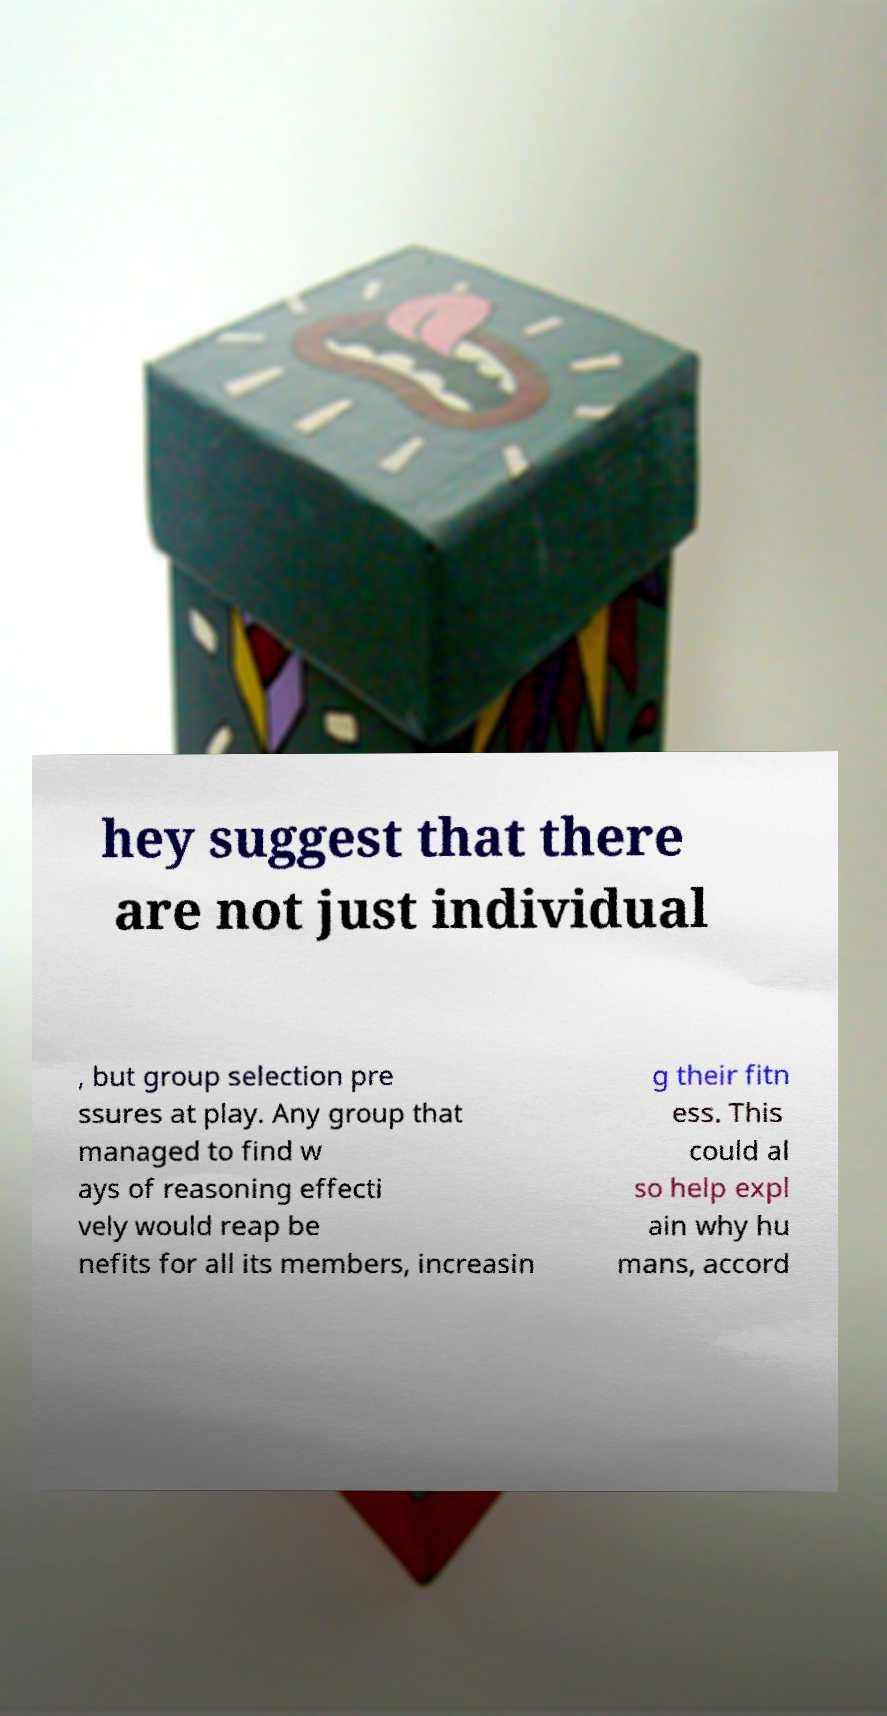What messages or text are displayed in this image? I need them in a readable, typed format. hey suggest that there are not just individual , but group selection pre ssures at play. Any group that managed to find w ays of reasoning effecti vely would reap be nefits for all its members, increasin g their fitn ess. This could al so help expl ain why hu mans, accord 